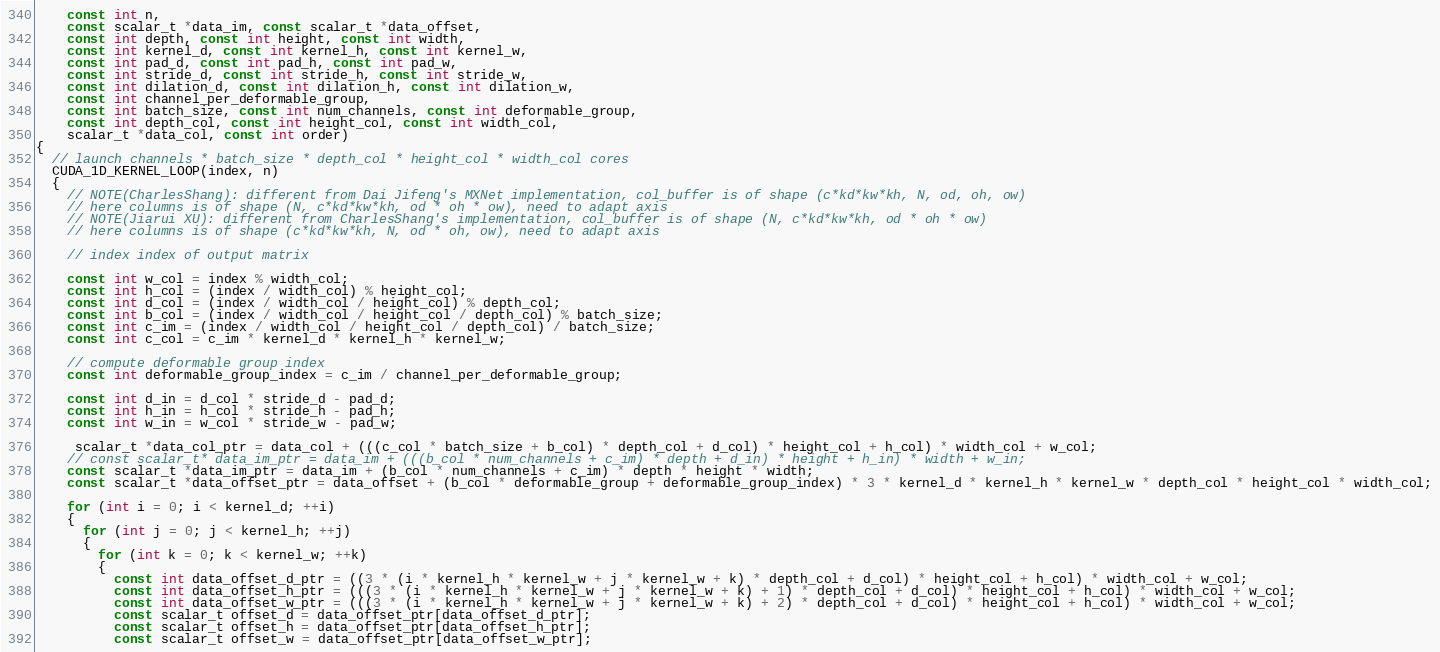<code> <loc_0><loc_0><loc_500><loc_500><_Cuda_>    const int n,
    const scalar_t *data_im, const scalar_t *data_offset,
    const int depth, const int height, const int width,
    const int kernel_d, const int kernel_h, const int kernel_w,
    const int pad_d, const int pad_h, const int pad_w,
    const int stride_d, const int stride_h, const int stride_w,
    const int dilation_d, const int dilation_h, const int dilation_w,
    const int channel_per_deformable_group,
    const int batch_size, const int num_channels, const int deformable_group,
    const int depth_col, const int height_col, const int width_col,
    scalar_t *data_col, const int order)
{
  // launch channels * batch_size * depth_col * height_col * width_col cores
  CUDA_1D_KERNEL_LOOP(index, n)
  {
    // NOTE(CharlesShang): different from Dai Jifeng's MXNet implementation, col_buffer is of shape (c*kd*kw*kh, N, od, oh, ow)
    // here columns is of shape (N, c*kd*kw*kh, od * oh * ow), need to adapt axis
    // NOTE(Jiarui XU): different from CharlesShang's implementation, col_buffer is of shape (N, c*kd*kw*kh, od * oh * ow)
    // here columns is of shape (c*kd*kw*kh, N, od * oh, ow), need to adapt axis

    // index index of output matrix

    const int w_col = index % width_col;
    const int h_col = (index / width_col) % height_col;
    const int d_col = (index / width_col / height_col) % depth_col;
    const int b_col = (index / width_col / height_col / depth_col) % batch_size;
    const int c_im = (index / width_col / height_col / depth_col) / batch_size;
    const int c_col = c_im * kernel_d * kernel_h * kernel_w;

    // compute deformable group index
    const int deformable_group_index = c_im / channel_per_deformable_group;

    const int d_in = d_col * stride_d - pad_d;
    const int h_in = h_col * stride_h - pad_h;
    const int w_in = w_col * stride_w - pad_w;

     scalar_t *data_col_ptr = data_col + (((c_col * batch_size + b_col) * depth_col + d_col) * height_col + h_col) * width_col + w_col;
    // const scalar_t* data_im_ptr = data_im + (((b_col * num_channels + c_im) * depth + d_in) * height + h_in) * width + w_in;
    const scalar_t *data_im_ptr = data_im + (b_col * num_channels + c_im) * depth * height * width;
    const scalar_t *data_offset_ptr = data_offset + (b_col * deformable_group + deformable_group_index) * 3 * kernel_d * kernel_h * kernel_w * depth_col * height_col * width_col;

    for (int i = 0; i < kernel_d; ++i)
    {
      for (int j = 0; j < kernel_h; ++j)
      {
        for (int k = 0; k < kernel_w; ++k)
        {
          const int data_offset_d_ptr = ((3 * (i * kernel_h * kernel_w + j * kernel_w + k) * depth_col + d_col) * height_col + h_col) * width_col + w_col;
          const int data_offset_h_ptr = (((3 * (i * kernel_h * kernel_w + j * kernel_w + k) + 1) * depth_col + d_col) * height_col + h_col) * width_col + w_col;
          const int data_offset_w_ptr = (((3 * (i * kernel_h * kernel_w + j * kernel_w + k) + 2) * depth_col + d_col) * height_col + h_col) * width_col + w_col;
          const scalar_t offset_d = data_offset_ptr[data_offset_d_ptr];
          const scalar_t offset_h = data_offset_ptr[data_offset_h_ptr];
          const scalar_t offset_w = data_offset_ptr[data_offset_w_ptr];</code> 